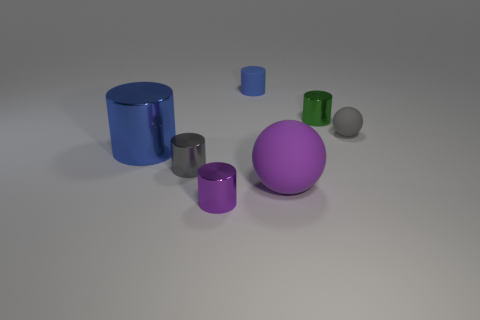Subtract all purple shiny cylinders. How many cylinders are left? 4 Add 3 purple cylinders. How many objects exist? 10 Subtract all blue cylinders. How many cylinders are left? 3 Subtract all spheres. How many objects are left? 5 Subtract 1 balls. How many balls are left? 1 Subtract all green spheres. How many blue cylinders are left? 2 Subtract all gray shiny objects. Subtract all purple balls. How many objects are left? 5 Add 7 gray spheres. How many gray spheres are left? 8 Add 3 tiny red objects. How many tiny red objects exist? 3 Subtract 0 brown blocks. How many objects are left? 7 